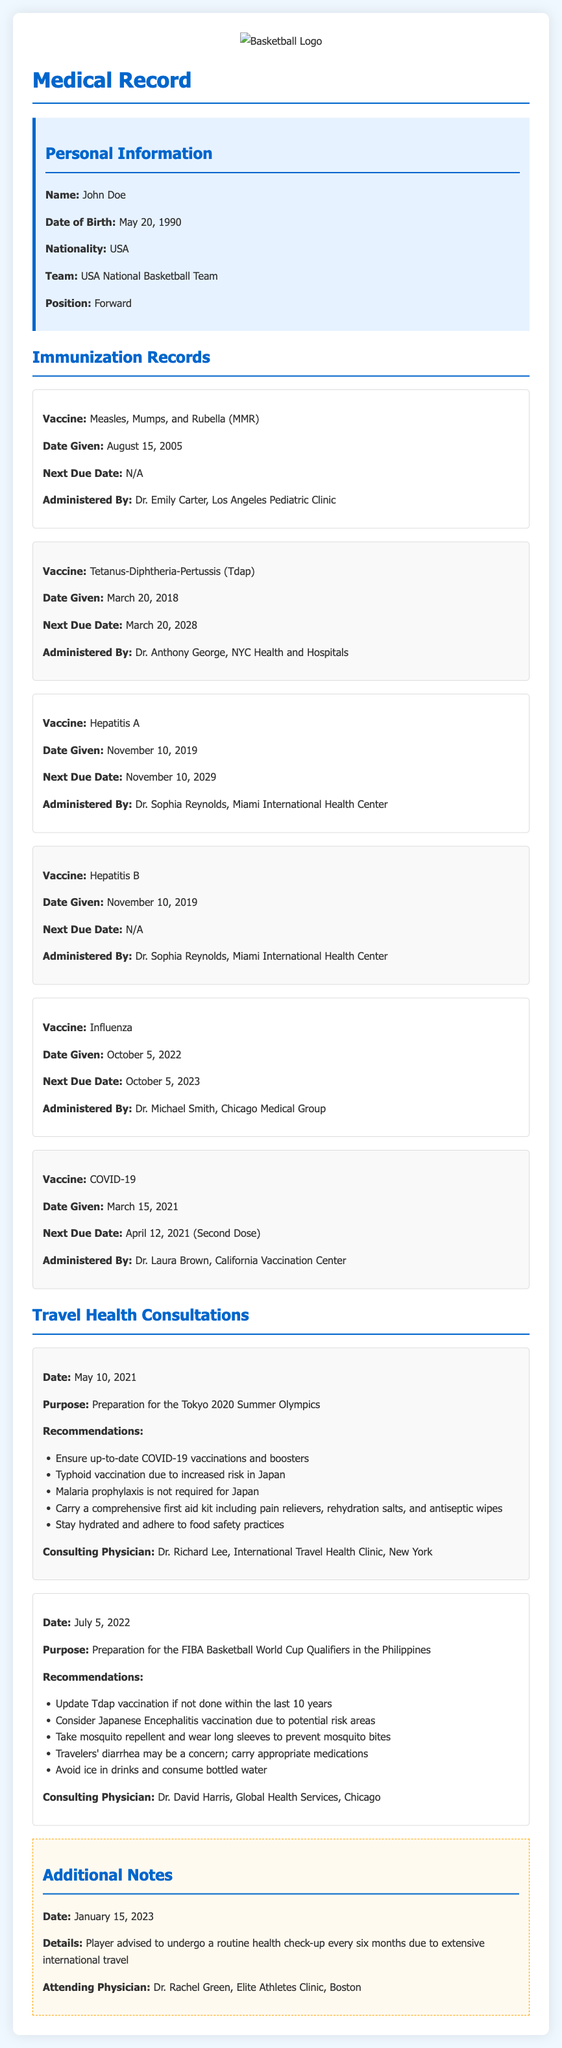What is the date of birth of John Doe? The date of birth of John Doe is listed in the personal information section of the document.
Answer: May 20, 1990 Who administered the Influenza vaccine? The name of the individual who administered the Influenza vaccine is provided in the immunization records section.
Answer: Dr. Michael Smith When is the next due date for the Tdap vaccine? The document specifies the next due date for the Tdap vaccine in the immunization records section.
Answer: March 20, 2028 What was the purpose of the consultation on May 10, 2021? The purpose of the consultation is detailed in the travel health consultations section of the document.
Answer: Preparation for the Tokyo 2020 Summer Olympics How many vaccines were administered in 2019? The immunization records provide information on the vaccines administered in that year.
Answer: 2 What is the recommendation regarding mosquito repellent for the Philippines trip? The document contains recommendations about mosquito repellent in the context of the Philippines trip.
Answer: Take mosquito repellent and wear long sleeves Who conducted the health check-up advice in January 2023? The attending physician for the health check-up advice is mentioned in the additional notes section.
Answer: Dr. Rachel Green Is malaria prophylaxis required for travel to Japan? The document explicitly states whether malaria prophylaxis is required for Japan in the travel health consultations.
Answer: No 